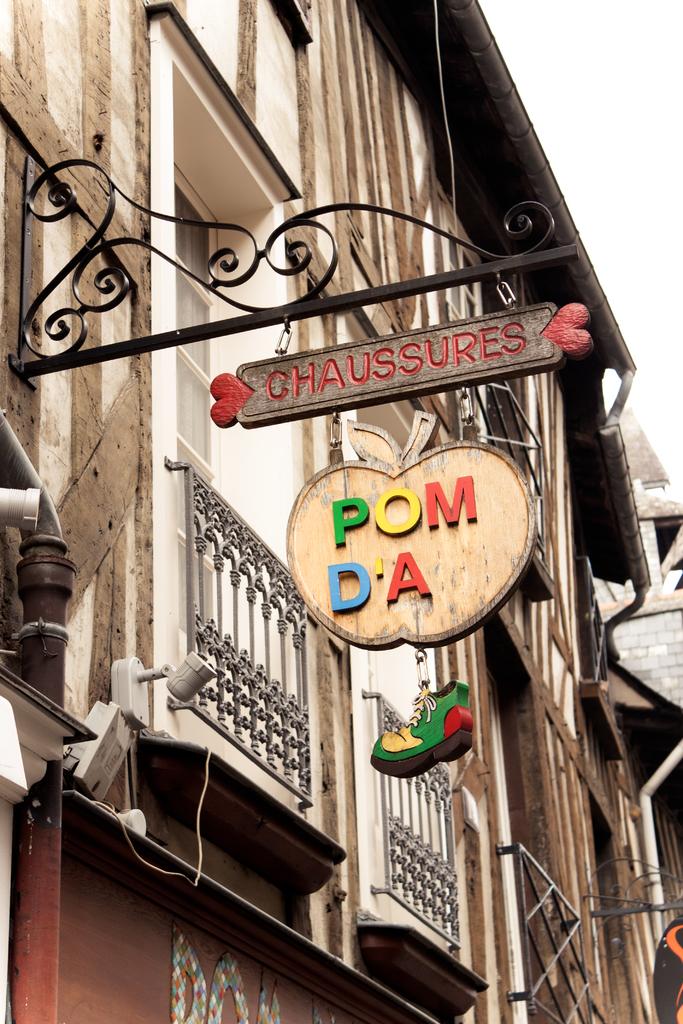What is the name of the restaurant?
Ensure brevity in your answer.  Chaussures. 